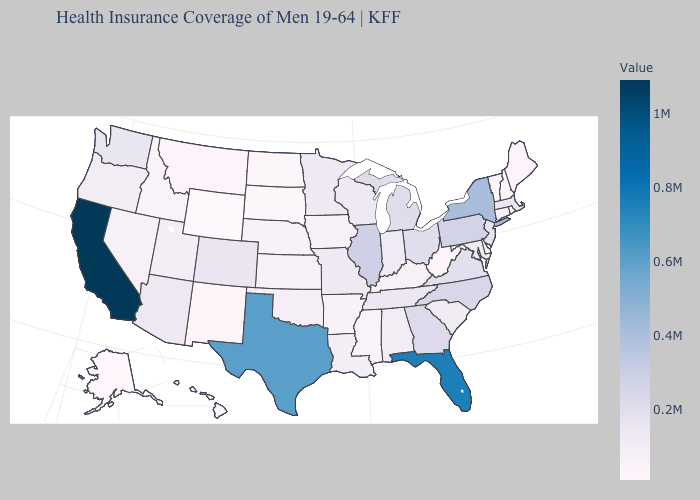Does Washington have a higher value than New Hampshire?
Concise answer only. Yes. 